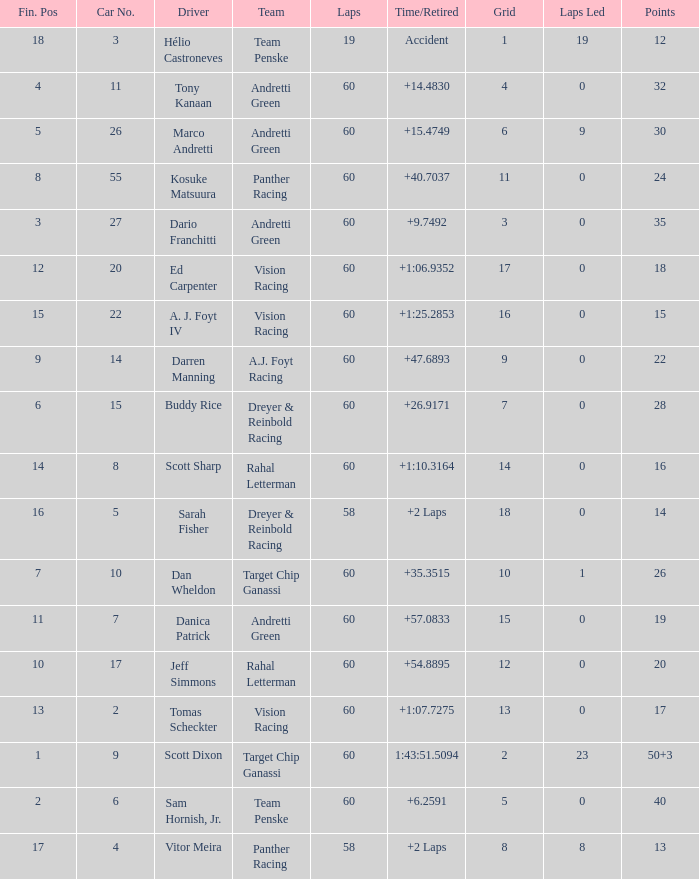Name the drive for points being 13 Vitor Meira. 